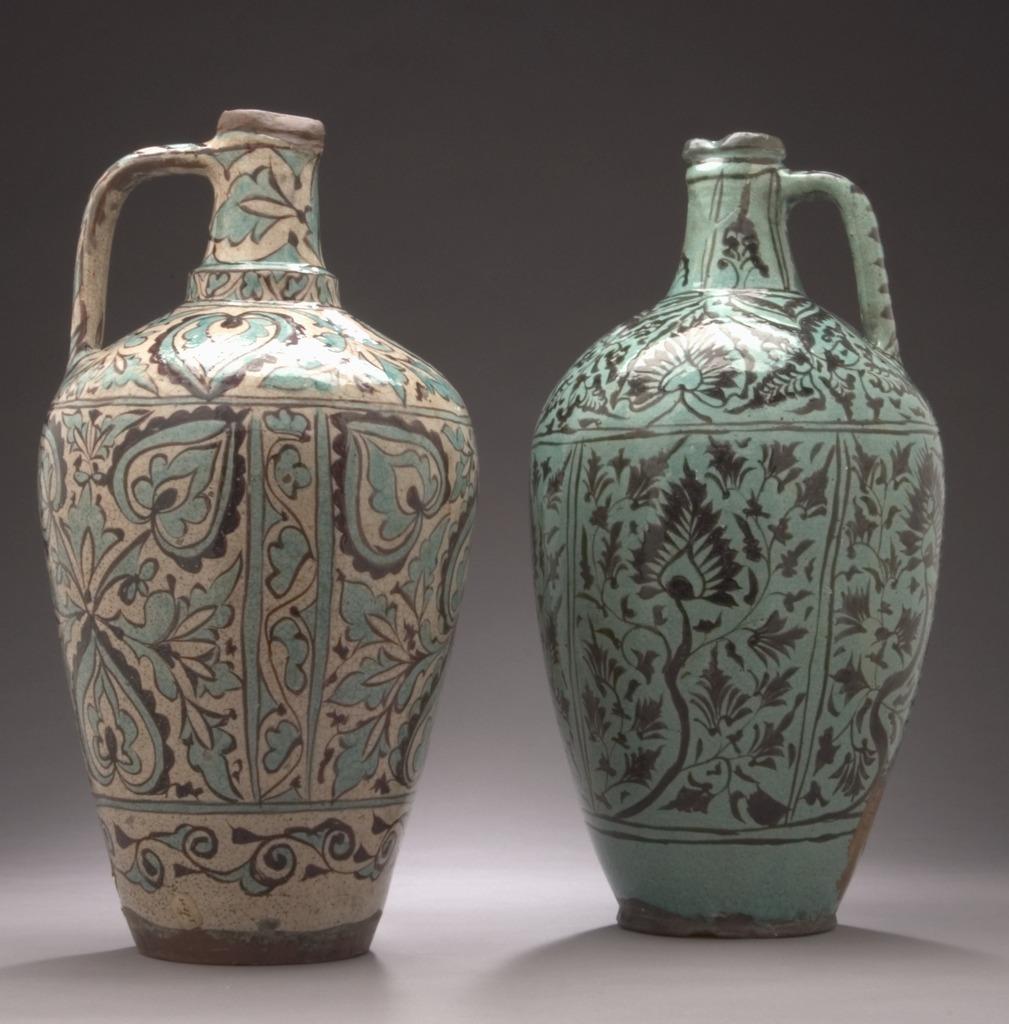In one or two sentences, can you explain what this image depicts? In the picture there are two pots present with the painting. 